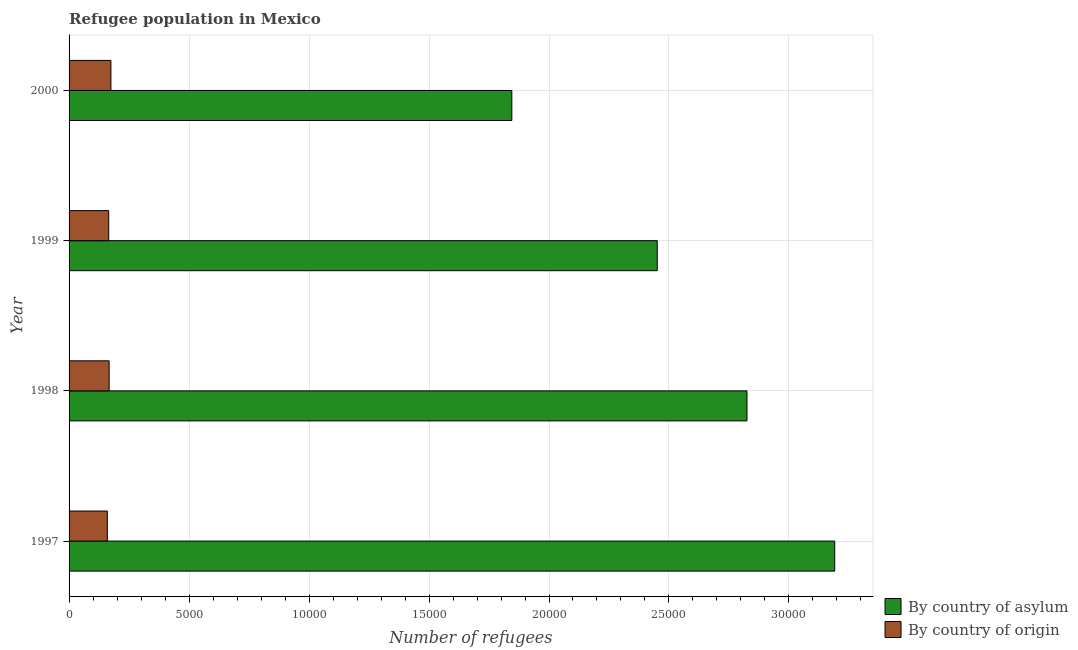How many groups of bars are there?
Offer a terse response. 4. Are the number of bars per tick equal to the number of legend labels?
Keep it short and to the point. Yes. What is the label of the 4th group of bars from the top?
Give a very brief answer. 1997. In how many cases, is the number of bars for a given year not equal to the number of legend labels?
Your response must be concise. 0. What is the number of refugees by country of origin in 1997?
Offer a very short reply. 1594. Across all years, what is the maximum number of refugees by country of asylum?
Your response must be concise. 3.19e+04. Across all years, what is the minimum number of refugees by country of origin?
Provide a short and direct response. 1594. In which year was the number of refugees by country of origin minimum?
Offer a terse response. 1997. What is the total number of refugees by country of asylum in the graph?
Provide a succinct answer. 1.03e+05. What is the difference between the number of refugees by country of origin in 1997 and that in 2000?
Your answer should be compact. -150. What is the difference between the number of refugees by country of asylum in 1999 and the number of refugees by country of origin in 1998?
Provide a succinct answer. 2.28e+04. What is the average number of refugees by country of asylum per year?
Offer a very short reply. 2.58e+04. In the year 1998, what is the difference between the number of refugees by country of origin and number of refugees by country of asylum?
Your answer should be very brief. -2.66e+04. In how many years, is the number of refugees by country of asylum greater than 12000 ?
Your answer should be very brief. 4. Is the number of refugees by country of asylum in 1998 less than that in 2000?
Your response must be concise. No. Is the difference between the number of refugees by country of asylum in 1998 and 1999 greater than the difference between the number of refugees by country of origin in 1998 and 1999?
Make the answer very short. Yes. What is the difference between the highest and the lowest number of refugees by country of origin?
Give a very brief answer. 150. In how many years, is the number of refugees by country of asylum greater than the average number of refugees by country of asylum taken over all years?
Make the answer very short. 2. What does the 1st bar from the top in 2000 represents?
Your answer should be compact. By country of origin. What does the 2nd bar from the bottom in 1998 represents?
Provide a succinct answer. By country of origin. How many bars are there?
Your response must be concise. 8. How many years are there in the graph?
Provide a short and direct response. 4. How many legend labels are there?
Make the answer very short. 2. How are the legend labels stacked?
Ensure brevity in your answer.  Vertical. What is the title of the graph?
Offer a terse response. Refugee population in Mexico. What is the label or title of the X-axis?
Provide a short and direct response. Number of refugees. What is the Number of refugees in By country of asylum in 1997?
Keep it short and to the point. 3.19e+04. What is the Number of refugees of By country of origin in 1997?
Keep it short and to the point. 1594. What is the Number of refugees of By country of asylum in 1998?
Your response must be concise. 2.83e+04. What is the Number of refugees of By country of origin in 1998?
Offer a very short reply. 1670. What is the Number of refugees in By country of asylum in 1999?
Your response must be concise. 2.45e+04. What is the Number of refugees in By country of origin in 1999?
Offer a very short reply. 1652. What is the Number of refugees of By country of asylum in 2000?
Your answer should be very brief. 1.85e+04. What is the Number of refugees of By country of origin in 2000?
Make the answer very short. 1744. Across all years, what is the maximum Number of refugees of By country of asylum?
Ensure brevity in your answer.  3.19e+04. Across all years, what is the maximum Number of refugees of By country of origin?
Provide a succinct answer. 1744. Across all years, what is the minimum Number of refugees in By country of asylum?
Provide a short and direct response. 1.85e+04. Across all years, what is the minimum Number of refugees in By country of origin?
Give a very brief answer. 1594. What is the total Number of refugees of By country of asylum in the graph?
Offer a terse response. 1.03e+05. What is the total Number of refugees in By country of origin in the graph?
Offer a very short reply. 6660. What is the difference between the Number of refugees in By country of asylum in 1997 and that in 1998?
Make the answer very short. 3657. What is the difference between the Number of refugees in By country of origin in 1997 and that in 1998?
Offer a terse response. -76. What is the difference between the Number of refugees of By country of asylum in 1997 and that in 1999?
Your answer should be very brief. 7397. What is the difference between the Number of refugees of By country of origin in 1997 and that in 1999?
Keep it short and to the point. -58. What is the difference between the Number of refugees of By country of asylum in 1997 and that in 2000?
Offer a very short reply. 1.35e+04. What is the difference between the Number of refugees in By country of origin in 1997 and that in 2000?
Keep it short and to the point. -150. What is the difference between the Number of refugees of By country of asylum in 1998 and that in 1999?
Your answer should be very brief. 3740. What is the difference between the Number of refugees of By country of origin in 1998 and that in 1999?
Offer a terse response. 18. What is the difference between the Number of refugees in By country of asylum in 1998 and that in 2000?
Give a very brief answer. 9800. What is the difference between the Number of refugees in By country of origin in 1998 and that in 2000?
Your answer should be very brief. -74. What is the difference between the Number of refugees of By country of asylum in 1999 and that in 2000?
Offer a terse response. 6060. What is the difference between the Number of refugees in By country of origin in 1999 and that in 2000?
Your response must be concise. -92. What is the difference between the Number of refugees of By country of asylum in 1997 and the Number of refugees of By country of origin in 1998?
Ensure brevity in your answer.  3.02e+04. What is the difference between the Number of refugees in By country of asylum in 1997 and the Number of refugees in By country of origin in 1999?
Keep it short and to the point. 3.03e+04. What is the difference between the Number of refugees of By country of asylum in 1997 and the Number of refugees of By country of origin in 2000?
Your response must be concise. 3.02e+04. What is the difference between the Number of refugees in By country of asylum in 1998 and the Number of refugees in By country of origin in 1999?
Make the answer very short. 2.66e+04. What is the difference between the Number of refugees of By country of asylum in 1998 and the Number of refugees of By country of origin in 2000?
Your response must be concise. 2.65e+04. What is the difference between the Number of refugees of By country of asylum in 1999 and the Number of refugees of By country of origin in 2000?
Your answer should be compact. 2.28e+04. What is the average Number of refugees of By country of asylum per year?
Make the answer very short. 2.58e+04. What is the average Number of refugees of By country of origin per year?
Offer a very short reply. 1665. In the year 1997, what is the difference between the Number of refugees of By country of asylum and Number of refugees of By country of origin?
Give a very brief answer. 3.03e+04. In the year 1998, what is the difference between the Number of refugees of By country of asylum and Number of refugees of By country of origin?
Offer a terse response. 2.66e+04. In the year 1999, what is the difference between the Number of refugees of By country of asylum and Number of refugees of By country of origin?
Give a very brief answer. 2.29e+04. In the year 2000, what is the difference between the Number of refugees in By country of asylum and Number of refugees in By country of origin?
Offer a terse response. 1.67e+04. What is the ratio of the Number of refugees in By country of asylum in 1997 to that in 1998?
Provide a succinct answer. 1.13. What is the ratio of the Number of refugees of By country of origin in 1997 to that in 1998?
Offer a very short reply. 0.95. What is the ratio of the Number of refugees in By country of asylum in 1997 to that in 1999?
Your response must be concise. 1.3. What is the ratio of the Number of refugees of By country of origin in 1997 to that in 1999?
Keep it short and to the point. 0.96. What is the ratio of the Number of refugees of By country of asylum in 1997 to that in 2000?
Give a very brief answer. 1.73. What is the ratio of the Number of refugees of By country of origin in 1997 to that in 2000?
Your answer should be compact. 0.91. What is the ratio of the Number of refugees in By country of asylum in 1998 to that in 1999?
Ensure brevity in your answer.  1.15. What is the ratio of the Number of refugees in By country of origin in 1998 to that in 1999?
Your answer should be very brief. 1.01. What is the ratio of the Number of refugees of By country of asylum in 1998 to that in 2000?
Provide a short and direct response. 1.53. What is the ratio of the Number of refugees in By country of origin in 1998 to that in 2000?
Ensure brevity in your answer.  0.96. What is the ratio of the Number of refugees in By country of asylum in 1999 to that in 2000?
Ensure brevity in your answer.  1.33. What is the ratio of the Number of refugees in By country of origin in 1999 to that in 2000?
Your answer should be compact. 0.95. What is the difference between the highest and the second highest Number of refugees of By country of asylum?
Offer a very short reply. 3657. What is the difference between the highest and the lowest Number of refugees of By country of asylum?
Make the answer very short. 1.35e+04. What is the difference between the highest and the lowest Number of refugees of By country of origin?
Your answer should be very brief. 150. 